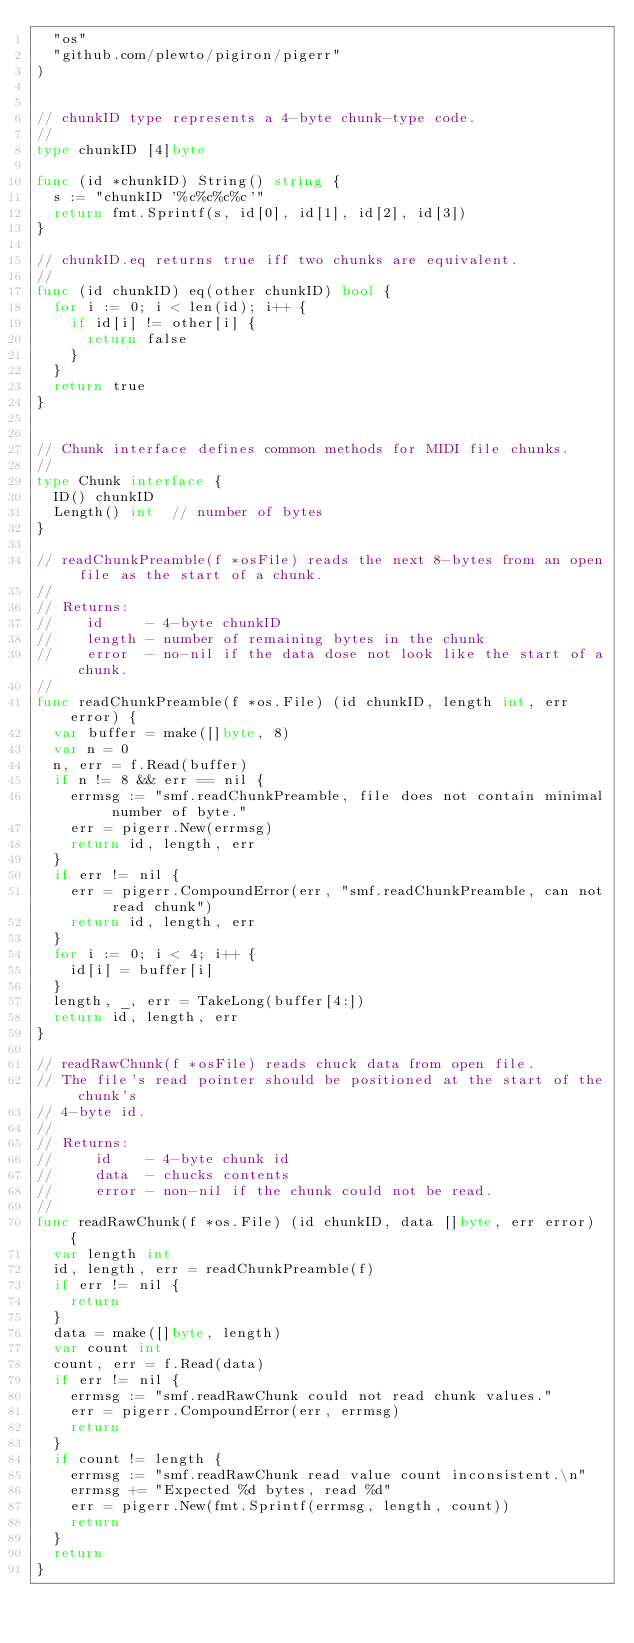Convert code to text. <code><loc_0><loc_0><loc_500><loc_500><_Go_>	"os"
	"github.com/plewto/pigiron/pigerr"
)


// chunkID type represents a 4-byte chunk-type code.
//
type chunkID [4]byte

func (id *chunkID) String() string {
	s := "chunkID '%c%c%c%c'"
	return fmt.Sprintf(s, id[0], id[1], id[2], id[3])
}

// chunkID.eq returns true iff two chunks are equivalent.
//
func (id chunkID) eq(other chunkID) bool {
	for i := 0; i < len(id); i++ {
		if id[i] != other[i] {
			return false
		}
	}
	return true
}


// Chunk interface defines common methods for MIDI file chunks.
//
type Chunk interface {
	ID() chunkID
	Length() int  // number of bytes
}

// readChunkPreamble(f *osFile) reads the next 8-bytes from an open file as the start of a chunk.
//
// Returns:
//    id     - 4-byte chunkID
//    length - number of remaining bytes in the chunk
//    error  - no-nil if the data dose not look like the start of a chunk.
//    
func readChunkPreamble(f *os.File) (id chunkID, length int, err error) {
	var buffer = make([]byte, 8)
	var n = 0
	n, err = f.Read(buffer)
	if n != 8 && err == nil {
		errmsg := "smf.readChunkPreamble, file does not contain minimal number of byte."
		err = pigerr.New(errmsg)
		return id, length, err
	}
	if err != nil {
		err = pigerr.CompoundError(err, "smf.readChunkPreamble, can not read chunk")
		return id, length, err
	}
	for i := 0; i < 4; i++ {
		id[i] = buffer[i]
	}
	length, _, err = TakeLong(buffer[4:])
	return id, length, err
}

// readRawChunk(f *osFile) reads chuck data from open file.
// The file's read pointer should be positioned at the start of the chunk's 
// 4-byte id.
//
// Returns:
//     id    - 4-byte chunk id
//     data  - chucks contents
//     error - non-nil if the chunk could not be read.
//
func readRawChunk(f *os.File) (id chunkID, data []byte, err error) {
	var length int
	id, length, err = readChunkPreamble(f)
	if err != nil {
		return
	}
	data = make([]byte, length)
	var count int
	count, err = f.Read(data)
	if err != nil {
		errmsg := "smf.readRawChunk could not read chunk values."
		err = pigerr.CompoundError(err, errmsg)
		return
	}
	if count != length {
		errmsg := "smf.readRawChunk read value count inconsistent.\n"
		errmsg += "Expected %d bytes, read %d"
		err = pigerr.New(fmt.Sprintf(errmsg, length, count))
		return
	}
	return
}



</code> 